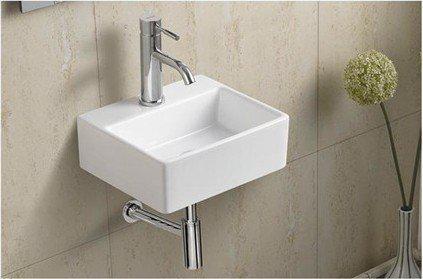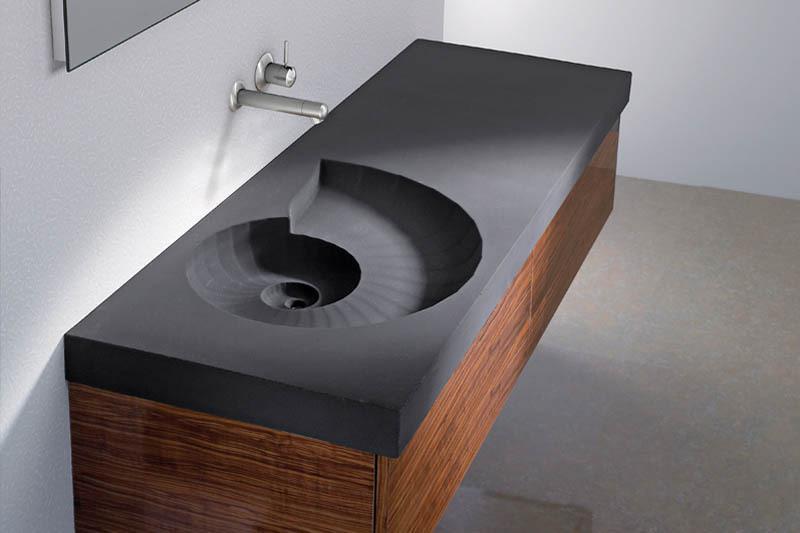The first image is the image on the left, the second image is the image on the right. Evaluate the accuracy of this statement regarding the images: "The sink in the right image has a black counter top.". Is it true? Answer yes or no. Yes. The first image is the image on the left, the second image is the image on the right. Assess this claim about the two images: "One image shows a rectangular vanity with a shell-shaped sink carved into it, beneath a fauced mounted on the wall.". Correct or not? Answer yes or no. Yes. 